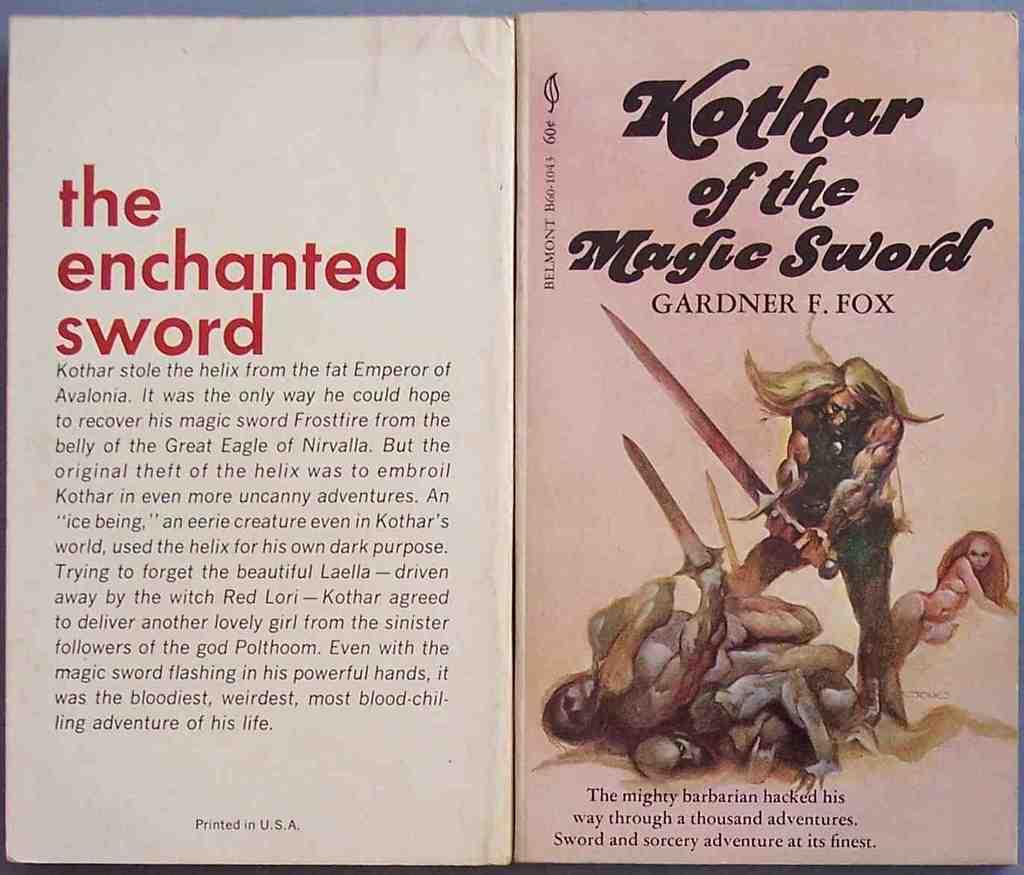In which country was the book printed?
Make the answer very short. Usa. Who illustrated the cover?
Keep it short and to the point. Gardner f. fox. 